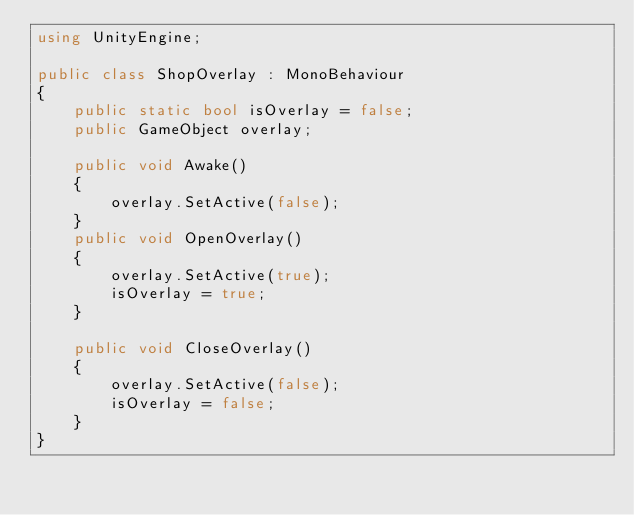<code> <loc_0><loc_0><loc_500><loc_500><_C#_>using UnityEngine;

public class ShopOverlay : MonoBehaviour
{
    public static bool isOverlay = false;
    public GameObject overlay;

    public void Awake()
    {
        overlay.SetActive(false);
    }
    public void OpenOverlay()
    {
        overlay.SetActive(true);
        isOverlay = true;
    }

    public void CloseOverlay()
    {
        overlay.SetActive(false);
        isOverlay = false;
    }
}
</code> 